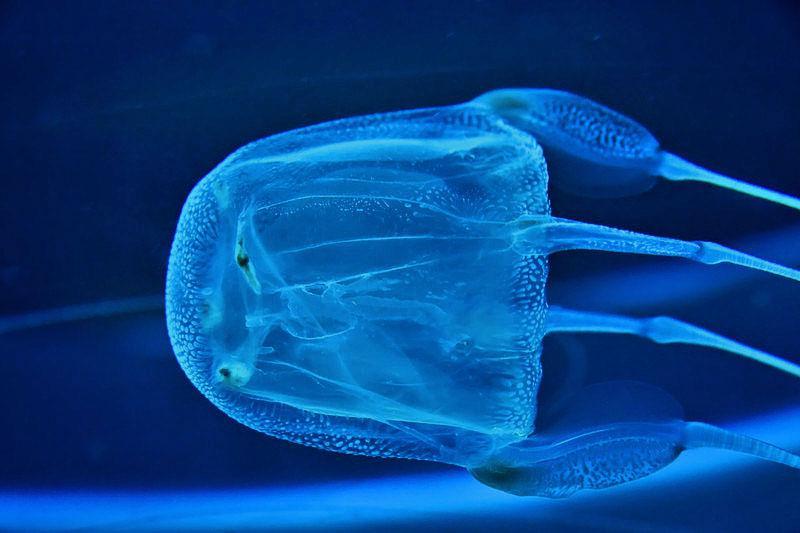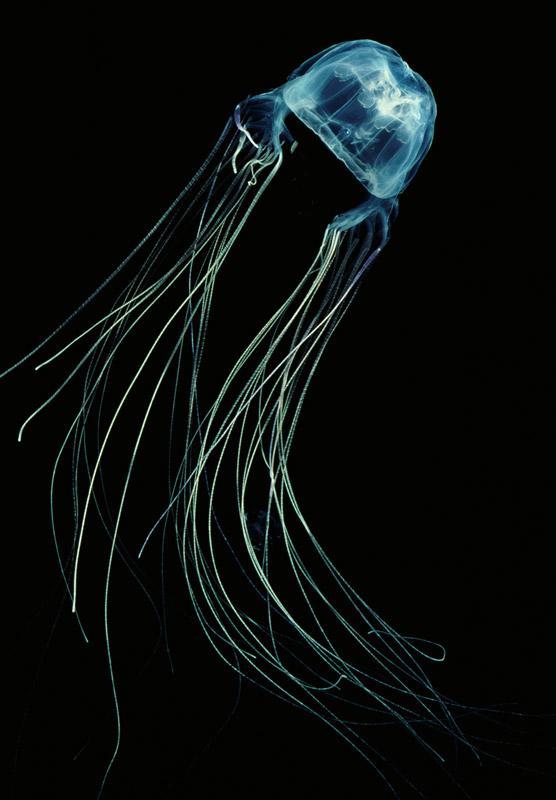The first image is the image on the left, the second image is the image on the right. For the images shown, is this caption "Both images show a single jellyfish with a black background." true? Answer yes or no. No. The first image is the image on the left, the second image is the image on the right. Evaluate the accuracy of this statement regarding the images: "in the left image the jellyfish is swimming straight up". Is it true? Answer yes or no. No. 